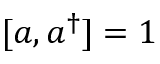Convert formula to latex. <formula><loc_0><loc_0><loc_500><loc_500>[ a , a ^ { \dagger } ] = 1</formula> 